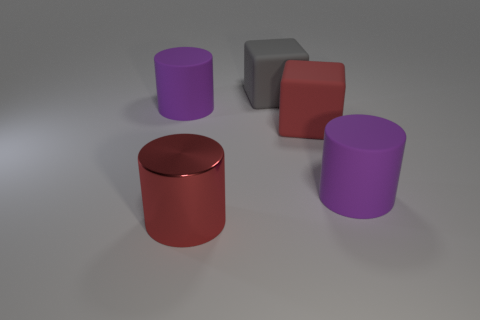Add 3 red cylinders. How many objects exist? 8 Subtract all cylinders. How many objects are left? 2 Add 3 large matte cylinders. How many large matte cylinders are left? 5 Add 1 big red cylinders. How many big red cylinders exist? 2 Subtract 0 gray balls. How many objects are left? 5 Subtract all purple matte things. Subtract all big purple cylinders. How many objects are left? 1 